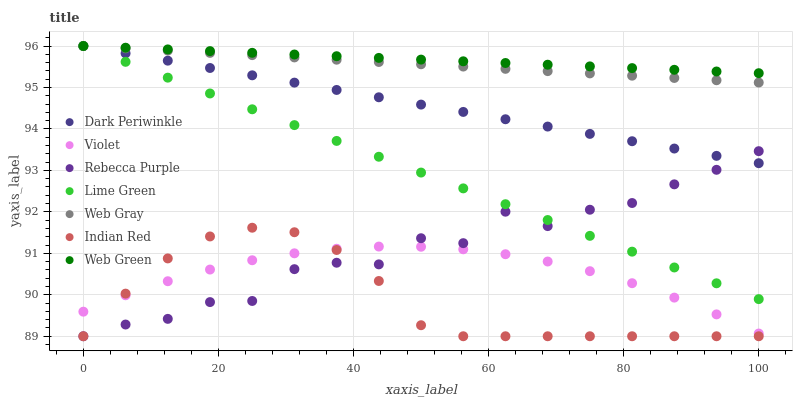Does Indian Red have the minimum area under the curve?
Answer yes or no. Yes. Does Web Green have the maximum area under the curve?
Answer yes or no. Yes. Does Rebecca Purple have the minimum area under the curve?
Answer yes or no. No. Does Rebecca Purple have the maximum area under the curve?
Answer yes or no. No. Is Web Gray the smoothest?
Answer yes or no. Yes. Is Rebecca Purple the roughest?
Answer yes or no. Yes. Is Web Green the smoothest?
Answer yes or no. No. Is Web Green the roughest?
Answer yes or no. No. Does Rebecca Purple have the lowest value?
Answer yes or no. Yes. Does Web Green have the lowest value?
Answer yes or no. No. Does Dark Periwinkle have the highest value?
Answer yes or no. Yes. Does Rebecca Purple have the highest value?
Answer yes or no. No. Is Indian Red less than Web Green?
Answer yes or no. Yes. Is Web Gray greater than Violet?
Answer yes or no. Yes. Does Web Green intersect Web Gray?
Answer yes or no. Yes. Is Web Green less than Web Gray?
Answer yes or no. No. Is Web Green greater than Web Gray?
Answer yes or no. No. Does Indian Red intersect Web Green?
Answer yes or no. No. 